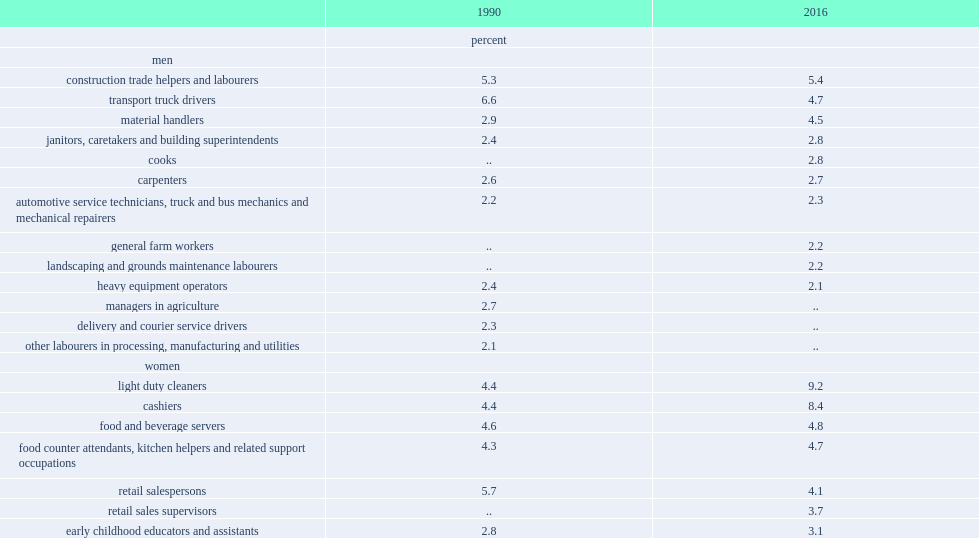Which two occupations were employing the most male workers with less than a high school diploma in 2016? Construction trade helpers and labourers transport truck drivers. Which two occupations were the most common male occupations in both 1990 and 2016? Construction trade helpers and labourers transport truck drivers. What is the most common occupation for male workers in 1990? Transport truck drivers. What is the percent of employed women without high school diploma for the top 10 occupations in 1990? 38. What is the percent of employed women without high school diploma for the top 10 occupations in 1990? 45.5. What are the top two female occupations in 1990? Retail salespersons food and beverage servers. What are the two most female occupations in 2016. Light duty cleaners cashiers. 